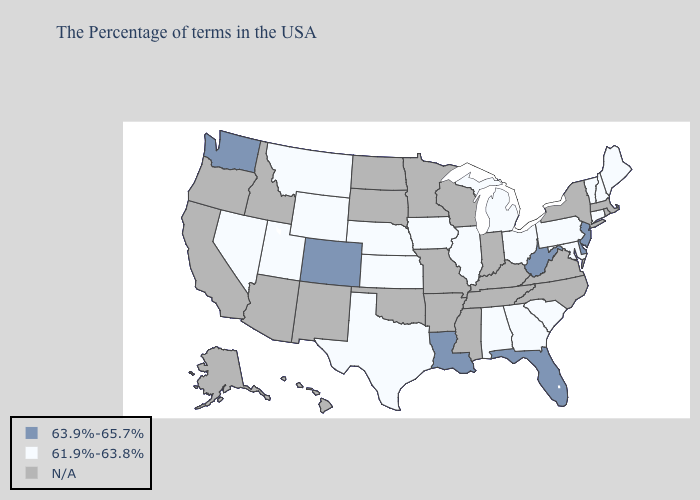What is the value of Michigan?
Be succinct. 61.9%-63.8%. What is the lowest value in the Northeast?
Concise answer only. 61.9%-63.8%. Name the states that have a value in the range N/A?
Give a very brief answer. Massachusetts, Rhode Island, New York, Virginia, North Carolina, Kentucky, Indiana, Tennessee, Wisconsin, Mississippi, Missouri, Arkansas, Minnesota, Oklahoma, South Dakota, North Dakota, New Mexico, Arizona, Idaho, California, Oregon, Alaska, Hawaii. Among the states that border Nebraska , does Colorado have the highest value?
Be succinct. Yes. Does New Jersey have the lowest value in the Northeast?
Short answer required. No. What is the value of Delaware?
Answer briefly. 63.9%-65.7%. What is the highest value in the USA?
Quick response, please. 63.9%-65.7%. Which states have the highest value in the USA?
Give a very brief answer. New Jersey, Delaware, West Virginia, Florida, Louisiana, Colorado, Washington. What is the lowest value in states that border Delaware?
Answer briefly. 61.9%-63.8%. Is the legend a continuous bar?
Be succinct. No. Name the states that have a value in the range N/A?
Write a very short answer. Massachusetts, Rhode Island, New York, Virginia, North Carolina, Kentucky, Indiana, Tennessee, Wisconsin, Mississippi, Missouri, Arkansas, Minnesota, Oklahoma, South Dakota, North Dakota, New Mexico, Arizona, Idaho, California, Oregon, Alaska, Hawaii. What is the value of Montana?
Give a very brief answer. 61.9%-63.8%. Name the states that have a value in the range N/A?
Write a very short answer. Massachusetts, Rhode Island, New York, Virginia, North Carolina, Kentucky, Indiana, Tennessee, Wisconsin, Mississippi, Missouri, Arkansas, Minnesota, Oklahoma, South Dakota, North Dakota, New Mexico, Arizona, Idaho, California, Oregon, Alaska, Hawaii. 